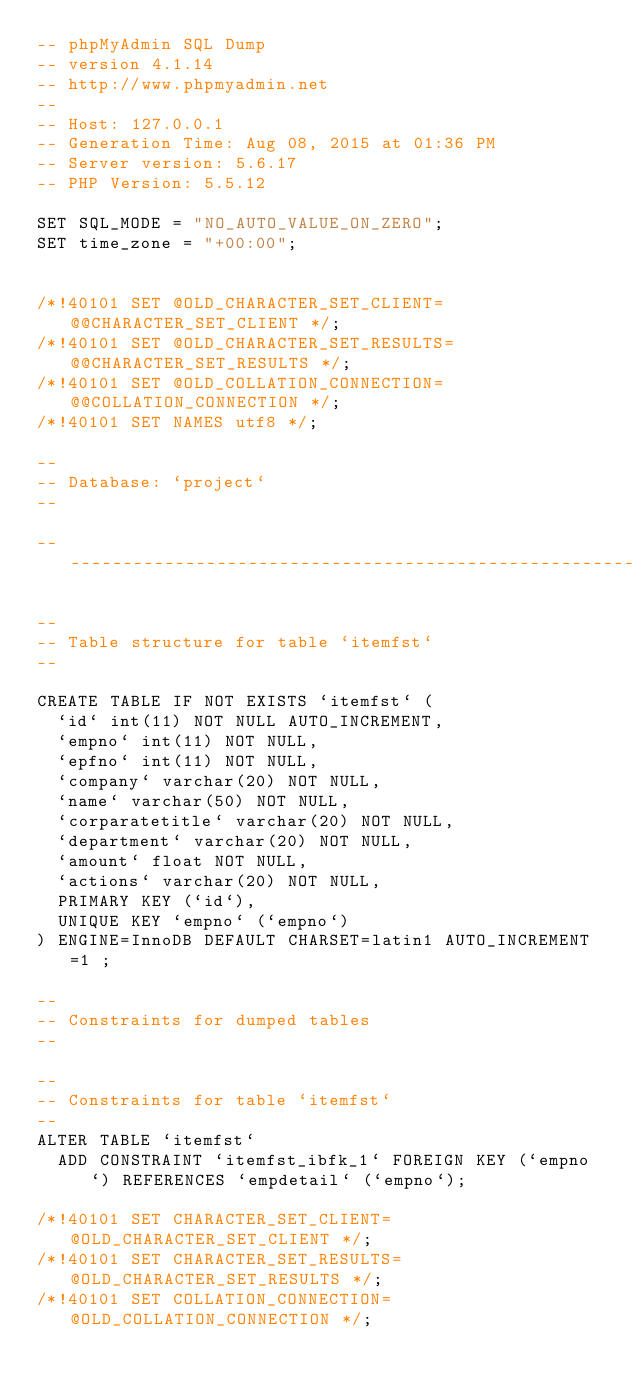<code> <loc_0><loc_0><loc_500><loc_500><_SQL_>-- phpMyAdmin SQL Dump
-- version 4.1.14
-- http://www.phpmyadmin.net
--
-- Host: 127.0.0.1
-- Generation Time: Aug 08, 2015 at 01:36 PM
-- Server version: 5.6.17
-- PHP Version: 5.5.12

SET SQL_MODE = "NO_AUTO_VALUE_ON_ZERO";
SET time_zone = "+00:00";


/*!40101 SET @OLD_CHARACTER_SET_CLIENT=@@CHARACTER_SET_CLIENT */;
/*!40101 SET @OLD_CHARACTER_SET_RESULTS=@@CHARACTER_SET_RESULTS */;
/*!40101 SET @OLD_COLLATION_CONNECTION=@@COLLATION_CONNECTION */;
/*!40101 SET NAMES utf8 */;

--
-- Database: `project`
--

-- --------------------------------------------------------

--
-- Table structure for table `itemfst`
--

CREATE TABLE IF NOT EXISTS `itemfst` (
  `id` int(11) NOT NULL AUTO_INCREMENT,
  `empno` int(11) NOT NULL,
  `epfno` int(11) NOT NULL,
  `company` varchar(20) NOT NULL,
  `name` varchar(50) NOT NULL,
  `corparatetitle` varchar(20) NOT NULL,
  `department` varchar(20) NOT NULL,
  `amount` float NOT NULL,
  `actions` varchar(20) NOT NULL,
  PRIMARY KEY (`id`),
  UNIQUE KEY `empno` (`empno`)
) ENGINE=InnoDB DEFAULT CHARSET=latin1 AUTO_INCREMENT=1 ;

--
-- Constraints for dumped tables
--

--
-- Constraints for table `itemfst`
--
ALTER TABLE `itemfst`
  ADD CONSTRAINT `itemfst_ibfk_1` FOREIGN KEY (`empno`) REFERENCES `empdetail` (`empno`);

/*!40101 SET CHARACTER_SET_CLIENT=@OLD_CHARACTER_SET_CLIENT */;
/*!40101 SET CHARACTER_SET_RESULTS=@OLD_CHARACTER_SET_RESULTS */;
/*!40101 SET COLLATION_CONNECTION=@OLD_COLLATION_CONNECTION */;
</code> 